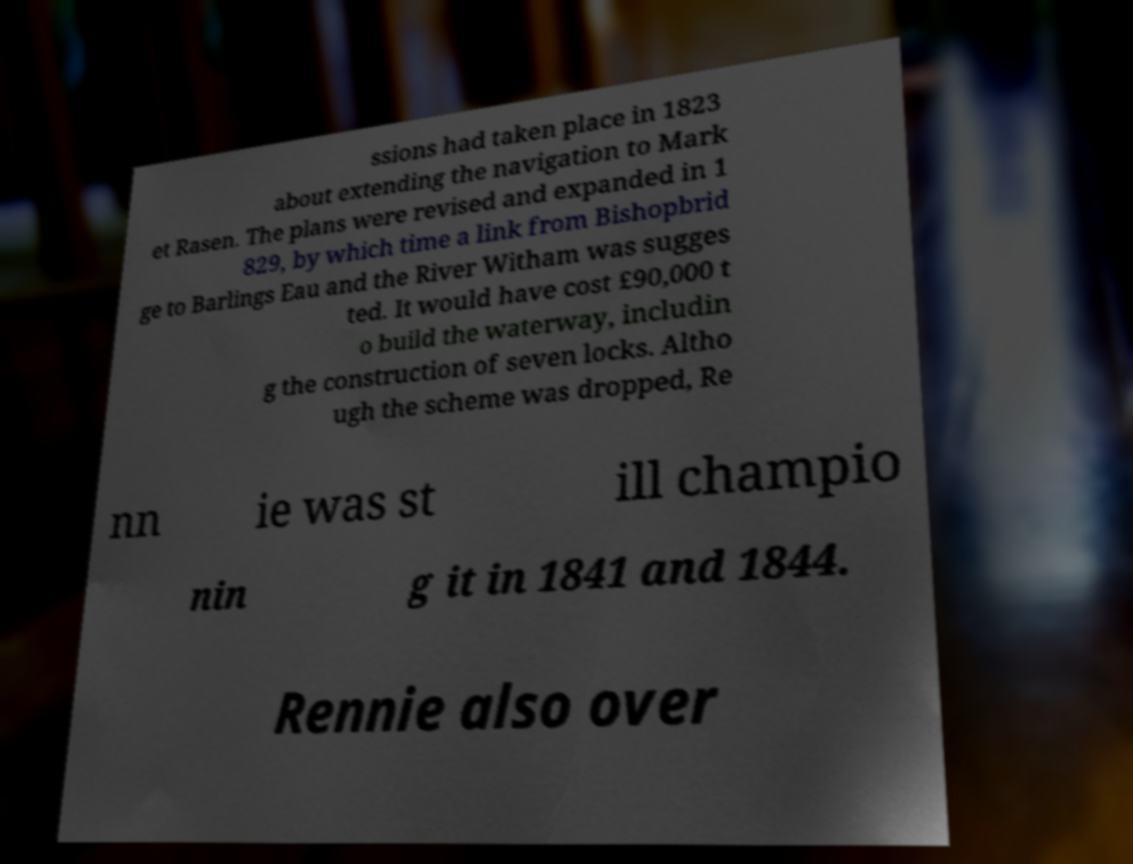Please identify and transcribe the text found in this image. ssions had taken place in 1823 about extending the navigation to Mark et Rasen. The plans were revised and expanded in 1 829, by which time a link from Bishopbrid ge to Barlings Eau and the River Witham was sugges ted. It would have cost £90,000 t o build the waterway, includin g the construction of seven locks. Altho ugh the scheme was dropped, Re nn ie was st ill champio nin g it in 1841 and 1844. Rennie also over 